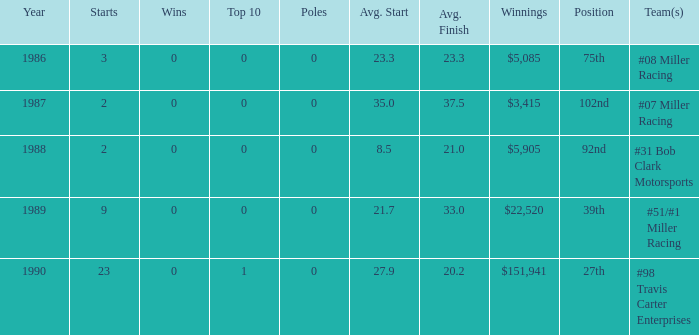What are the racing teams for which the average finish is 23.3? #08 Miller Racing. 